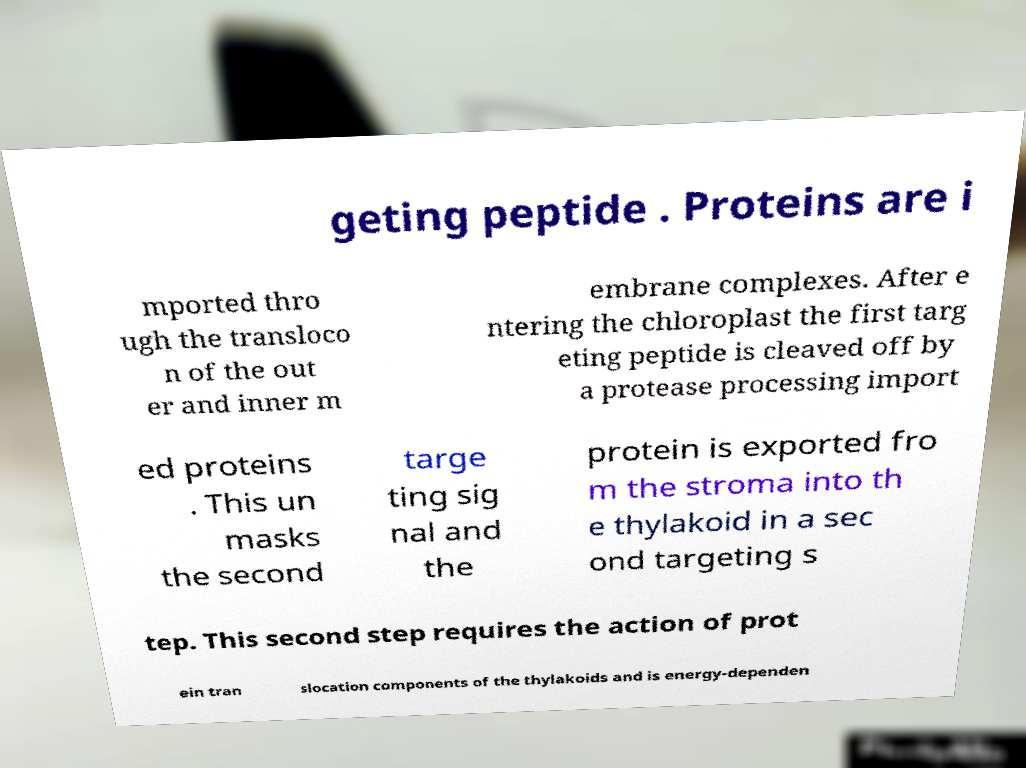I need the written content from this picture converted into text. Can you do that? geting peptide . Proteins are i mported thro ugh the transloco n of the out er and inner m embrane complexes. After e ntering the chloroplast the first targ eting peptide is cleaved off by a protease processing import ed proteins . This un masks the second targe ting sig nal and the protein is exported fro m the stroma into th e thylakoid in a sec ond targeting s tep. This second step requires the action of prot ein tran slocation components of the thylakoids and is energy-dependen 